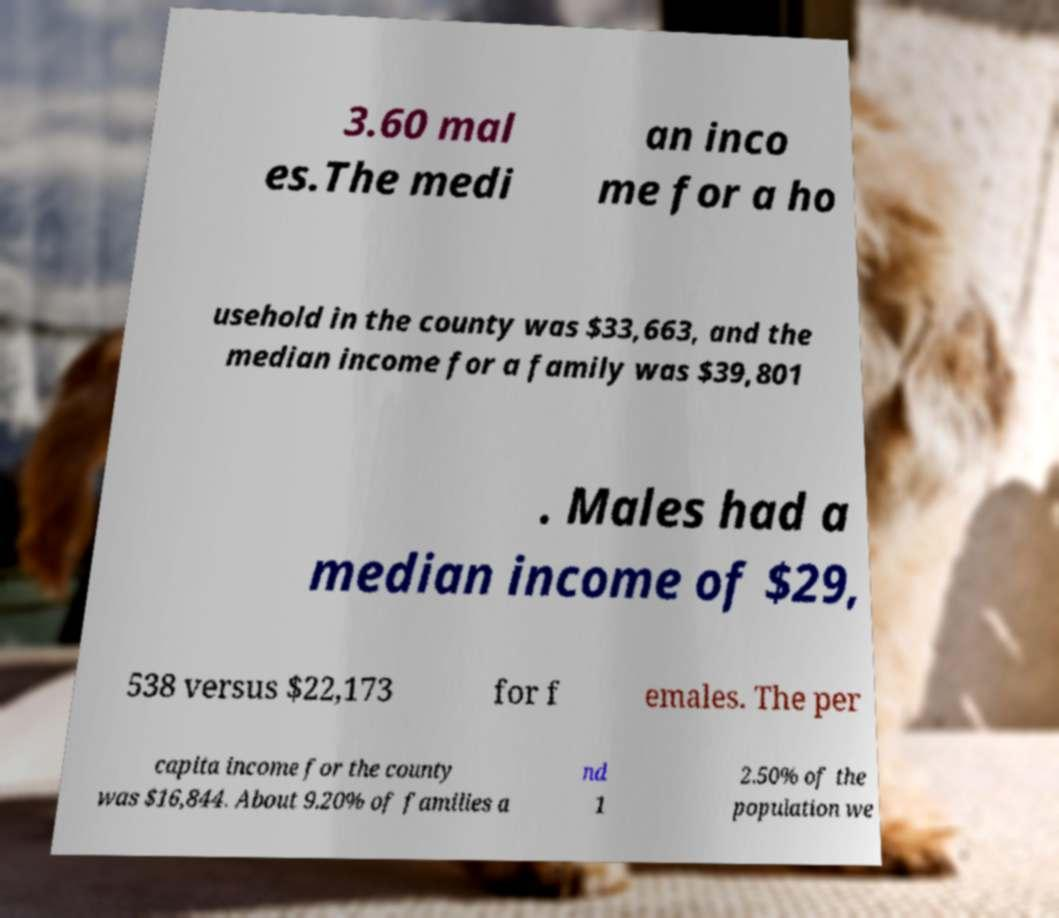Please read and relay the text visible in this image. What does it say? 3.60 mal es.The medi an inco me for a ho usehold in the county was $33,663, and the median income for a family was $39,801 . Males had a median income of $29, 538 versus $22,173 for f emales. The per capita income for the county was $16,844. About 9.20% of families a nd 1 2.50% of the population we 